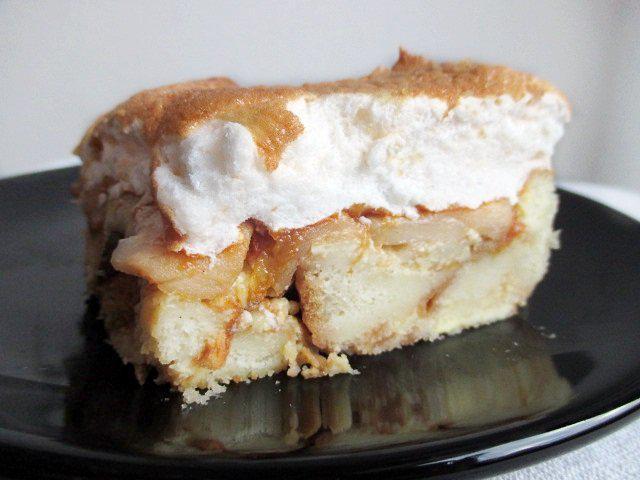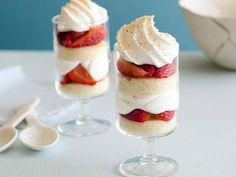The first image is the image on the left, the second image is the image on the right. For the images displayed, is the sentence "There is one large trifle bowl that has fresh strawberries and blueberries on top." factually correct? Answer yes or no. No. The first image is the image on the left, the second image is the image on the right. Evaluate the accuracy of this statement regarding the images: "There are two dessert cups sitting in a diagonal line in the image on the right.". Is it true? Answer yes or no. Yes. 